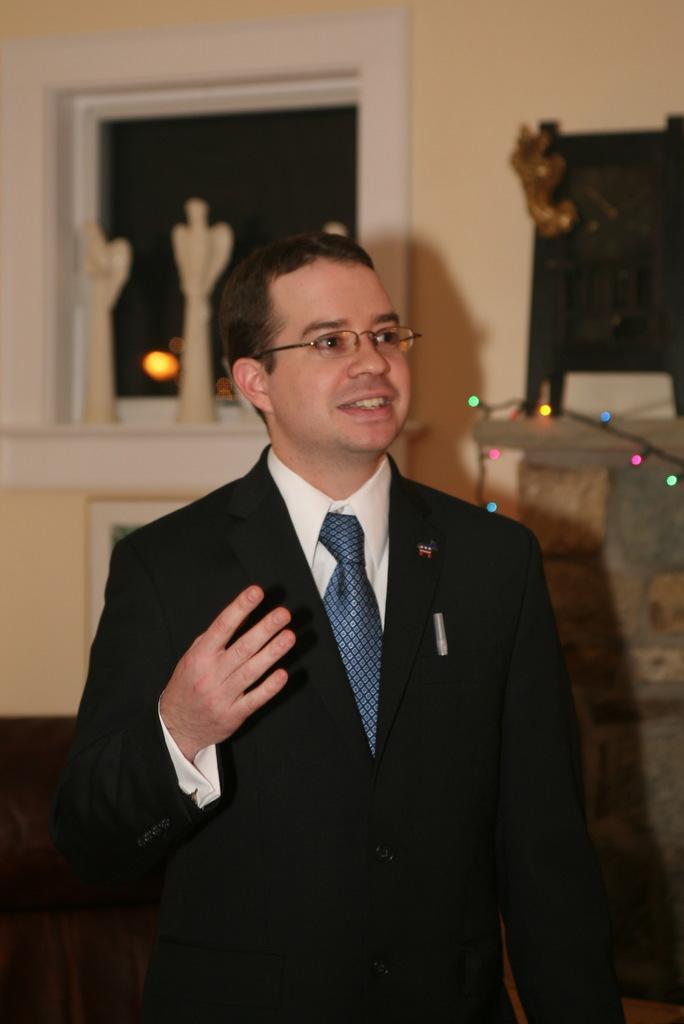Please provide a concise description of this image. The man in front of the picture wearing a white shirt and black blazer is standing. He is wearing the spectacles and he is smiling. I think he is trying to talk something. Behind him, we see a white wall and a window. On the right side, we see a table on which black color thing is placed. This picture is clicked inside the room. 